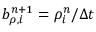Convert formula to latex. <formula><loc_0><loc_0><loc_500><loc_500>b _ { \rho , i } ^ { n + 1 } = \rho _ { i } ^ { n } / \Delta t</formula> 